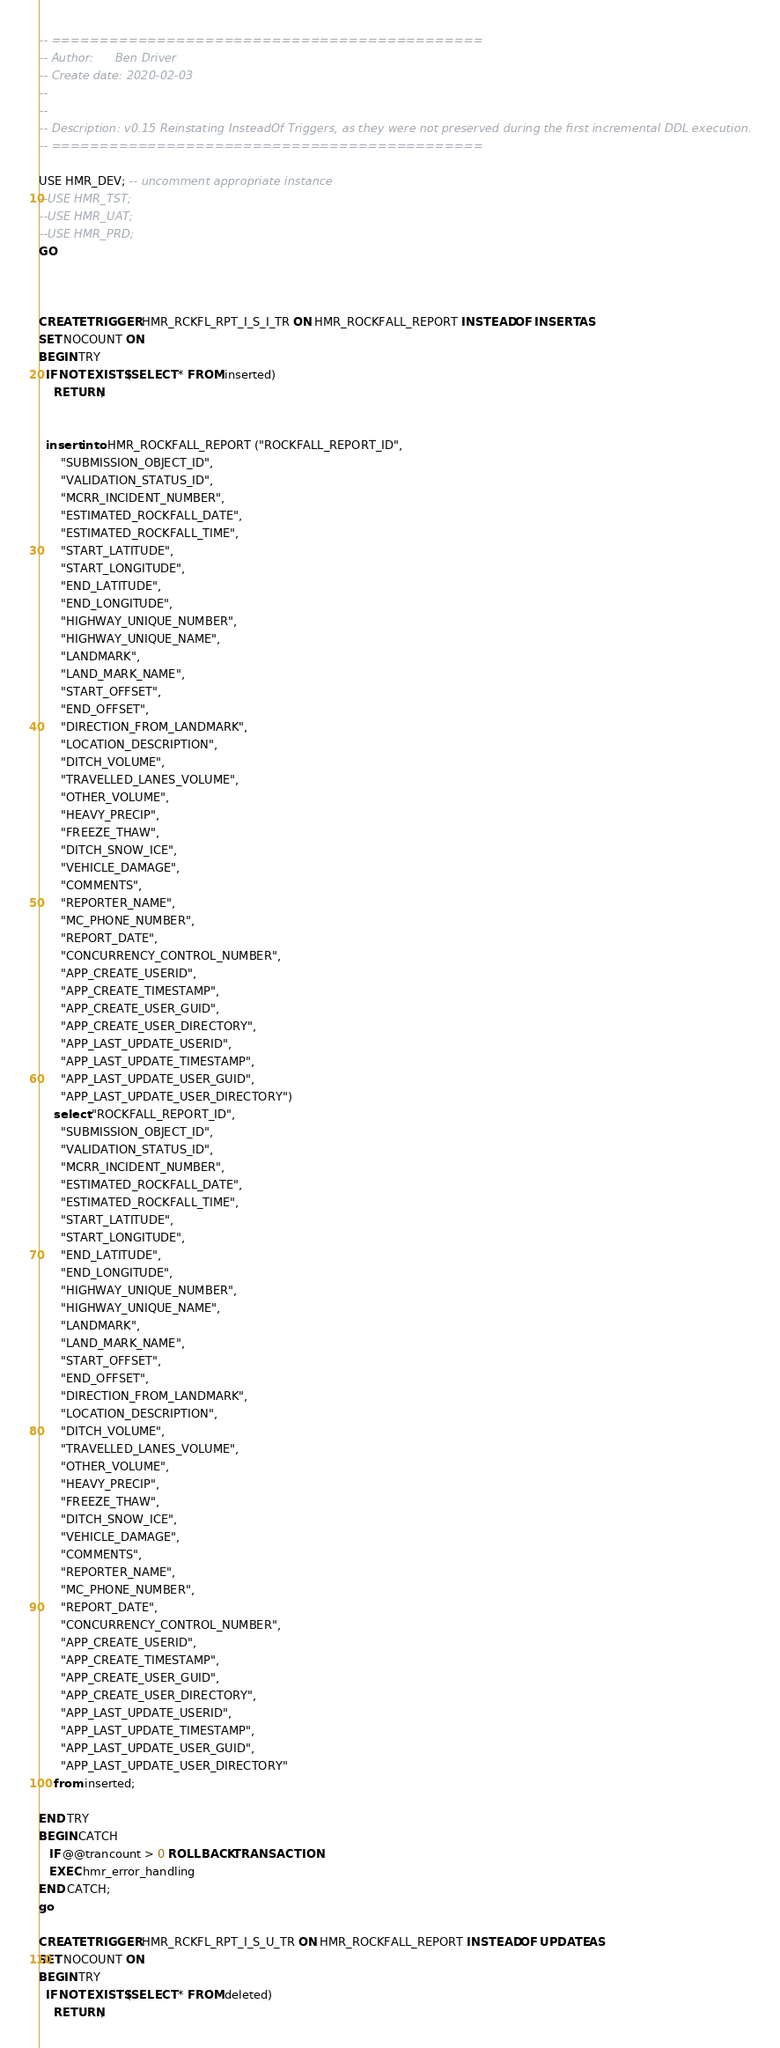Convert code to text. <code><loc_0><loc_0><loc_500><loc_500><_SQL_>-- =============================================
-- Author:		Ben Driver
-- Create date: 2020-02-03
-- 
-- 
-- Description:	v0.15 Reinstating InsteadOf Triggers, as they were not preserved during the first incremental DDL execution.
-- =============================================

USE HMR_DEV; -- uncomment appropriate instance
--USE HMR_TST;
--USE HMR_UAT;
--USE HMR_PRD;
GO



CREATE TRIGGER HMR_RCKFL_RPT_I_S_I_TR ON HMR_ROCKFALL_REPORT INSTEAD OF INSERT AS
SET NOCOUNT ON
BEGIN TRY
  IF NOT EXISTS(SELECT * FROM inserted) 
    RETURN;

  
  insert into HMR_ROCKFALL_REPORT ("ROCKFALL_REPORT_ID",
      "SUBMISSION_OBJECT_ID",
      "VALIDATION_STATUS_ID",
      "MCRR_INCIDENT_NUMBER",
      "ESTIMATED_ROCKFALL_DATE",
      "ESTIMATED_ROCKFALL_TIME",
      "START_LATITUDE",
      "START_LONGITUDE",
      "END_LATITUDE",
      "END_LONGITUDE",
      "HIGHWAY_UNIQUE_NUMBER",
      "HIGHWAY_UNIQUE_NAME",
      "LANDMARK",
      "LAND_MARK_NAME",
      "START_OFFSET",
      "END_OFFSET",
      "DIRECTION_FROM_LANDMARK",
      "LOCATION_DESCRIPTION",
      "DITCH_VOLUME",
      "TRAVELLED_LANES_VOLUME",
      "OTHER_VOLUME",
      "HEAVY_PRECIP",
      "FREEZE_THAW",
      "DITCH_SNOW_ICE",
      "VEHICLE_DAMAGE",
      "COMMENTS",
      "REPORTER_NAME",
      "MC_PHONE_NUMBER",
      "REPORT_DATE",
      "CONCURRENCY_CONTROL_NUMBER",
      "APP_CREATE_USERID",
      "APP_CREATE_TIMESTAMP",
      "APP_CREATE_USER_GUID",
      "APP_CREATE_USER_DIRECTORY",
      "APP_LAST_UPDATE_USERID",
      "APP_LAST_UPDATE_TIMESTAMP",
      "APP_LAST_UPDATE_USER_GUID",
      "APP_LAST_UPDATE_USER_DIRECTORY")
    select "ROCKFALL_REPORT_ID",
      "SUBMISSION_OBJECT_ID",
      "VALIDATION_STATUS_ID",
      "MCRR_INCIDENT_NUMBER",
      "ESTIMATED_ROCKFALL_DATE",
      "ESTIMATED_ROCKFALL_TIME",
      "START_LATITUDE",
      "START_LONGITUDE",
      "END_LATITUDE",
      "END_LONGITUDE",
      "HIGHWAY_UNIQUE_NUMBER",
      "HIGHWAY_UNIQUE_NAME",
      "LANDMARK",
      "LAND_MARK_NAME",
      "START_OFFSET",
      "END_OFFSET",
      "DIRECTION_FROM_LANDMARK",
      "LOCATION_DESCRIPTION",
      "DITCH_VOLUME",
      "TRAVELLED_LANES_VOLUME",
      "OTHER_VOLUME",
      "HEAVY_PRECIP",
      "FREEZE_THAW",
      "DITCH_SNOW_ICE",
      "VEHICLE_DAMAGE",
      "COMMENTS",
      "REPORTER_NAME",
      "MC_PHONE_NUMBER",
      "REPORT_DATE",
      "CONCURRENCY_CONTROL_NUMBER",
      "APP_CREATE_USERID",
      "APP_CREATE_TIMESTAMP",
      "APP_CREATE_USER_GUID",
      "APP_CREATE_USER_DIRECTORY",
      "APP_LAST_UPDATE_USERID",
      "APP_LAST_UPDATE_TIMESTAMP",
      "APP_LAST_UPDATE_USER_GUID",
      "APP_LAST_UPDATE_USER_DIRECTORY"
    from inserted;

END TRY
BEGIN CATCH
   IF @@trancount > 0 ROLLBACK TRANSACTION
   EXEC hmr_error_handling
END CATCH;
go

CREATE TRIGGER HMR_RCKFL_RPT_I_S_U_TR ON HMR_ROCKFALL_REPORT INSTEAD OF UPDATE AS
SET NOCOUNT ON
BEGIN TRY
  IF NOT EXISTS(SELECT * FROM deleted) 
    RETURN;
</code> 